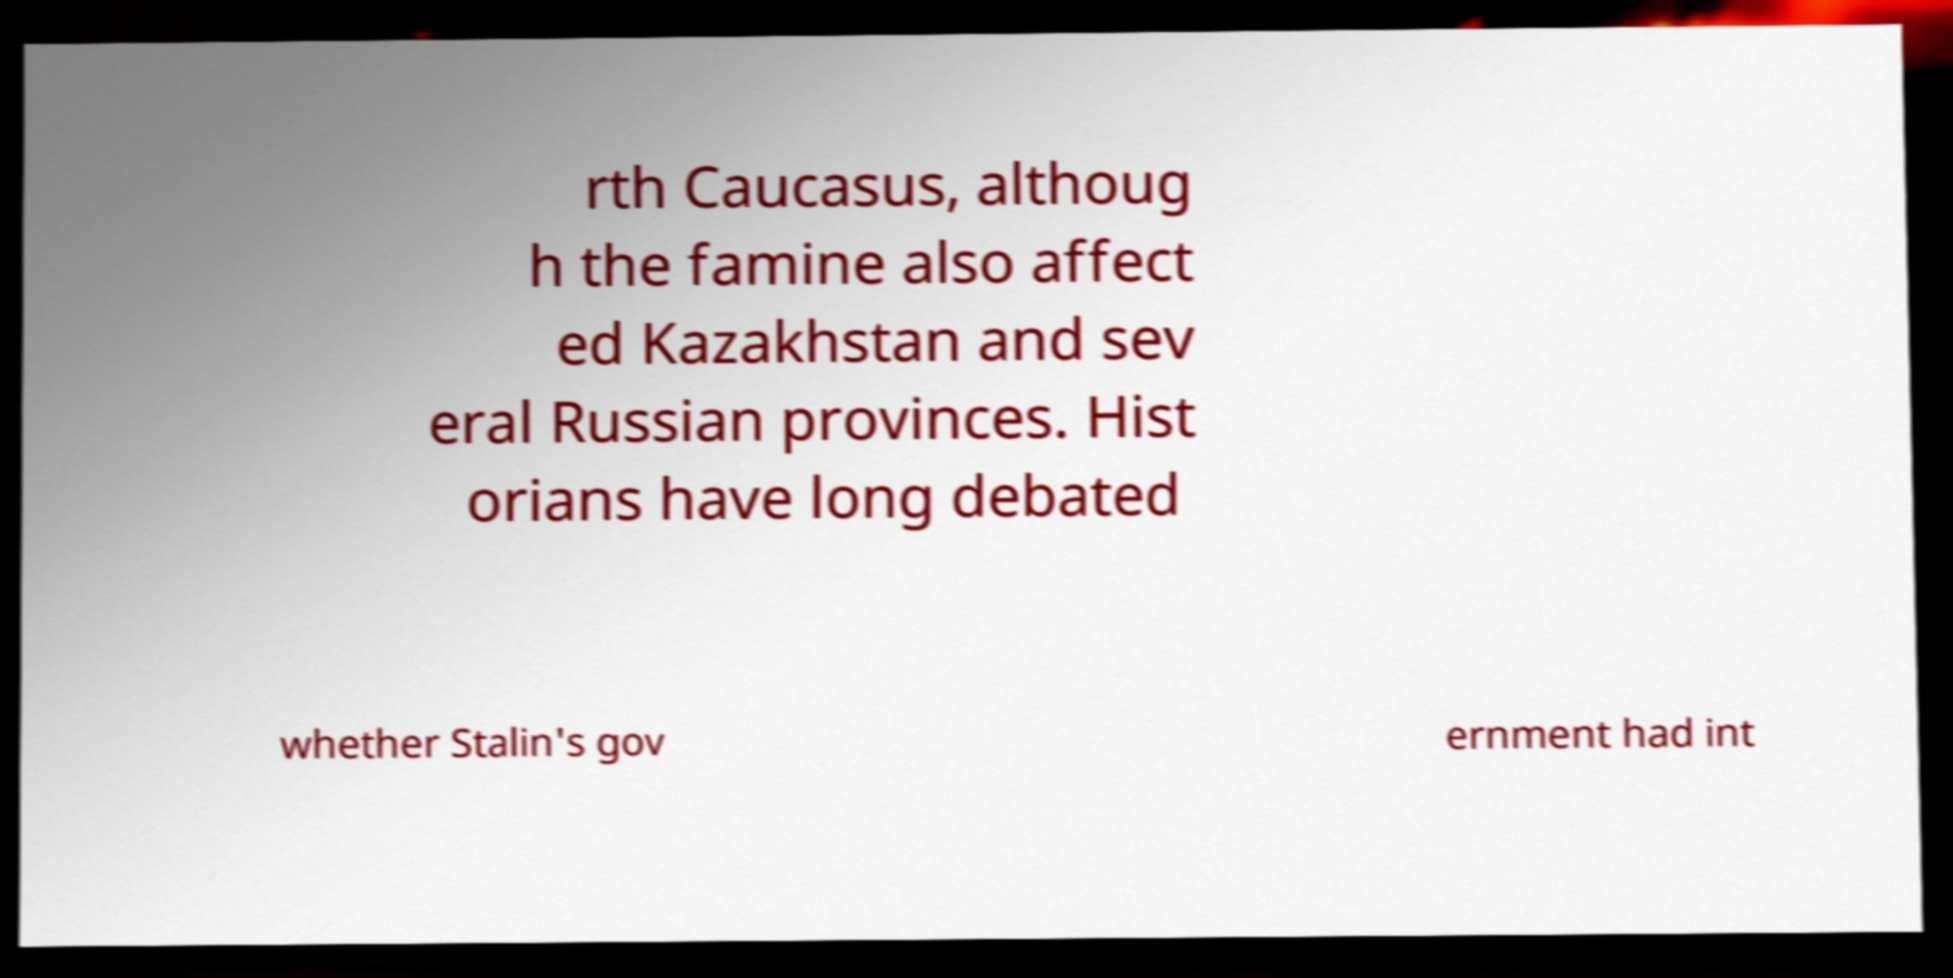Could you extract and type out the text from this image? rth Caucasus, althoug h the famine also affect ed Kazakhstan and sev eral Russian provinces. Hist orians have long debated whether Stalin's gov ernment had int 